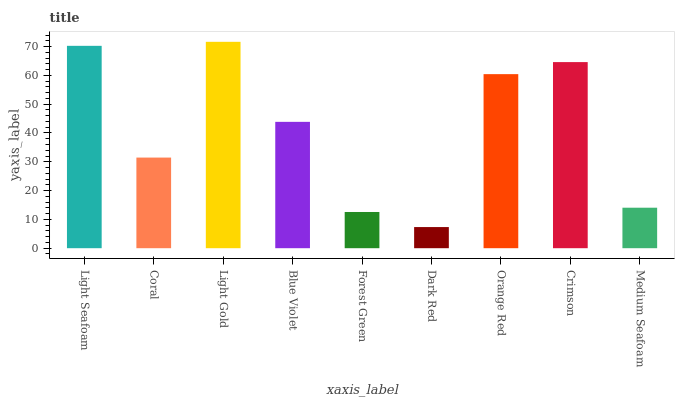Is Dark Red the minimum?
Answer yes or no. Yes. Is Light Gold the maximum?
Answer yes or no. Yes. Is Coral the minimum?
Answer yes or no. No. Is Coral the maximum?
Answer yes or no. No. Is Light Seafoam greater than Coral?
Answer yes or no. Yes. Is Coral less than Light Seafoam?
Answer yes or no. Yes. Is Coral greater than Light Seafoam?
Answer yes or no. No. Is Light Seafoam less than Coral?
Answer yes or no. No. Is Blue Violet the high median?
Answer yes or no. Yes. Is Blue Violet the low median?
Answer yes or no. Yes. Is Medium Seafoam the high median?
Answer yes or no. No. Is Forest Green the low median?
Answer yes or no. No. 